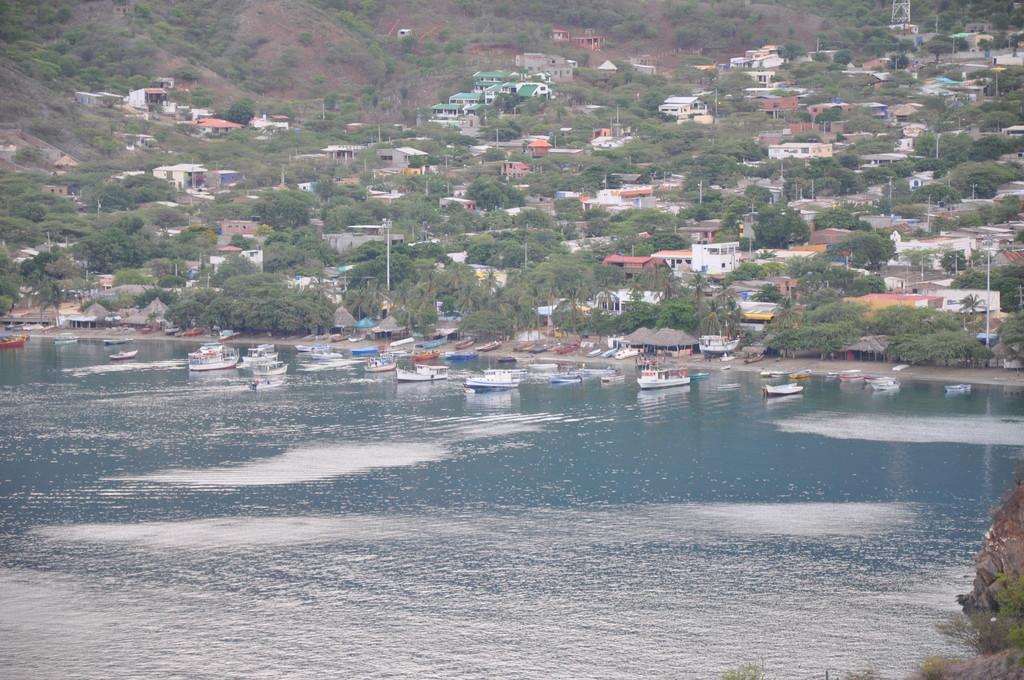Please provide a concise description of this image. In this image I can see few boats on the water, background I can see the trees in green color, few buildings in white, cream and green color and I can also see few poles. 